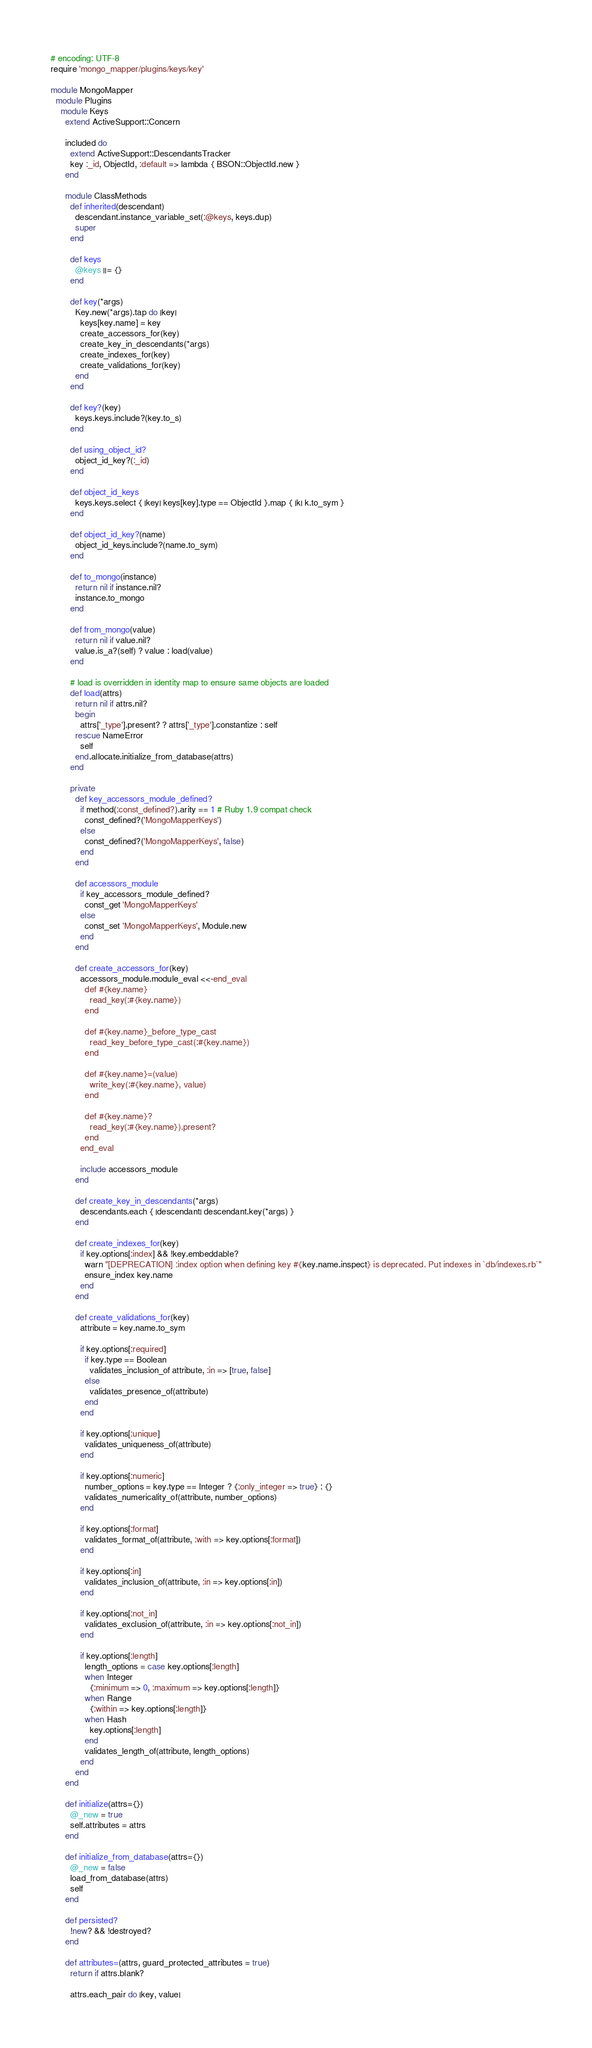<code> <loc_0><loc_0><loc_500><loc_500><_Ruby_># encoding: UTF-8
require 'mongo_mapper/plugins/keys/key'

module MongoMapper
  module Plugins
    module Keys
      extend ActiveSupport::Concern

      included do
        extend ActiveSupport::DescendantsTracker
        key :_id, ObjectId, :default => lambda { BSON::ObjectId.new }
      end

      module ClassMethods
        def inherited(descendant)
          descendant.instance_variable_set(:@keys, keys.dup)
          super
        end

        def keys
          @keys ||= {}
        end

        def key(*args)
          Key.new(*args).tap do |key|
            keys[key.name] = key
            create_accessors_for(key)
            create_key_in_descendants(*args)
            create_indexes_for(key)
            create_validations_for(key)
          end
        end

        def key?(key)
          keys.keys.include?(key.to_s)
        end

        def using_object_id?
          object_id_key?(:_id)
        end

        def object_id_keys
          keys.keys.select { |key| keys[key].type == ObjectId }.map { |k| k.to_sym }
        end

        def object_id_key?(name)
          object_id_keys.include?(name.to_sym)
        end

        def to_mongo(instance)
          return nil if instance.nil?
          instance.to_mongo
        end

        def from_mongo(value)
          return nil if value.nil?
          value.is_a?(self) ? value : load(value)
        end

        # load is overridden in identity map to ensure same objects are loaded
        def load(attrs)
          return nil if attrs.nil?
          begin
            attrs['_type'].present? ? attrs['_type'].constantize : self
          rescue NameError
            self
          end.allocate.initialize_from_database(attrs)
        end

        private
          def key_accessors_module_defined?
            if method(:const_defined?).arity == 1 # Ruby 1.9 compat check
              const_defined?('MongoMapperKeys')
            else
              const_defined?('MongoMapperKeys', false)
            end
          end

          def accessors_module
            if key_accessors_module_defined?
              const_get 'MongoMapperKeys'
            else
              const_set 'MongoMapperKeys', Module.new
            end
          end

          def create_accessors_for(key)
            accessors_module.module_eval <<-end_eval
              def #{key.name}
                read_key(:#{key.name})
              end

              def #{key.name}_before_type_cast
                read_key_before_type_cast(:#{key.name})
              end

              def #{key.name}=(value)
                write_key(:#{key.name}, value)
              end

              def #{key.name}?
                read_key(:#{key.name}).present?
              end
            end_eval

            include accessors_module
          end

          def create_key_in_descendants(*args)
            descendants.each { |descendant| descendant.key(*args) }
          end

          def create_indexes_for(key)
            if key.options[:index] && !key.embeddable?
              warn "[DEPRECATION] :index option when defining key #{key.name.inspect} is deprecated. Put indexes in `db/indexes.rb`"
              ensure_index key.name
            end
          end

          def create_validations_for(key)
            attribute = key.name.to_sym

            if key.options[:required]
              if key.type == Boolean
                validates_inclusion_of attribute, :in => [true, false]
              else
                validates_presence_of(attribute)
              end
            end

            if key.options[:unique]
              validates_uniqueness_of(attribute)
            end

            if key.options[:numeric]
              number_options = key.type == Integer ? {:only_integer => true} : {}
              validates_numericality_of(attribute, number_options)
            end

            if key.options[:format]
              validates_format_of(attribute, :with => key.options[:format])
            end

            if key.options[:in]
              validates_inclusion_of(attribute, :in => key.options[:in])
            end

            if key.options[:not_in]
              validates_exclusion_of(attribute, :in => key.options[:not_in])
            end

            if key.options[:length]
              length_options = case key.options[:length]
              when Integer
                {:minimum => 0, :maximum => key.options[:length]}
              when Range
                {:within => key.options[:length]}
              when Hash
                key.options[:length]
              end
              validates_length_of(attribute, length_options)
            end
          end
      end

      def initialize(attrs={})
        @_new = true
        self.attributes = attrs
      end

      def initialize_from_database(attrs={})
        @_new = false
        load_from_database(attrs)
        self
      end

      def persisted?
        !new? && !destroyed?
      end

      def attributes=(attrs, guard_protected_attributes = true)
        return if attrs.blank?

        attrs.each_pair do |key, value|</code> 